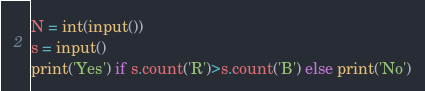Convert code to text. <code><loc_0><loc_0><loc_500><loc_500><_Python_>N = int(input())
s = input()
print('Yes') if s.count('R')>s.count('B') else print('No')</code> 